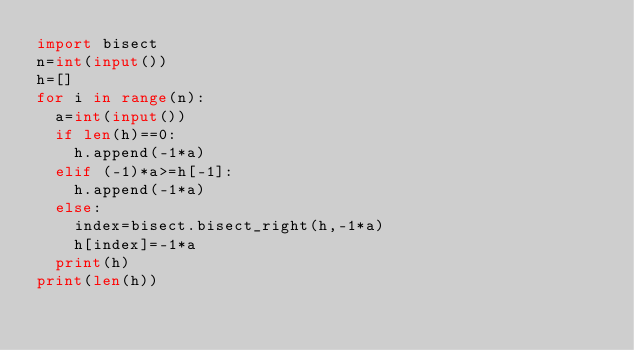Convert code to text. <code><loc_0><loc_0><loc_500><loc_500><_Python_>import bisect
n=int(input())
h=[]
for i in range(n):
  a=int(input())
  if len(h)==0:
    h.append(-1*a)
  elif (-1)*a>=h[-1]:
    h.append(-1*a)
  else:
    index=bisect.bisect_right(h,-1*a)
    h[index]=-1*a
  print(h)
print(len(h))</code> 